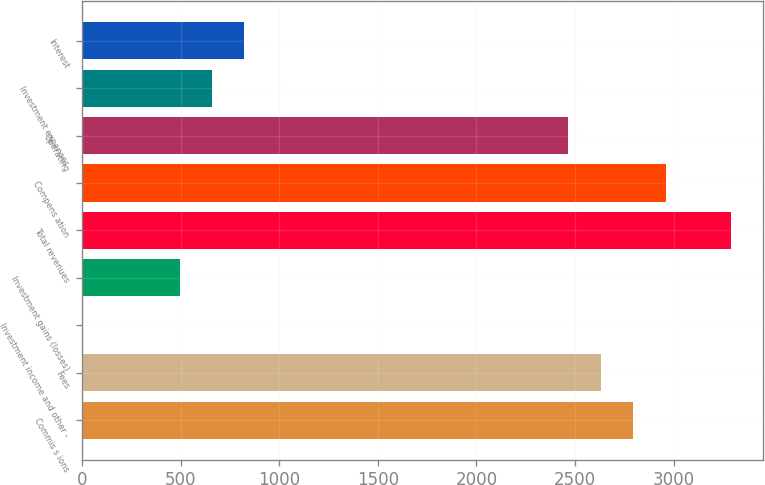<chart> <loc_0><loc_0><loc_500><loc_500><bar_chart><fcel>Commis s ions<fcel>Fees<fcel>Investment income and other -<fcel>Investment gains (losses)<fcel>Total revenues<fcel>Compens ation<fcel>Operating<fcel>Investment expenses<fcel>Interest<nl><fcel>2795.94<fcel>2631.52<fcel>0.8<fcel>494.06<fcel>3289.2<fcel>2960.36<fcel>2467.1<fcel>658.48<fcel>822.9<nl></chart> 